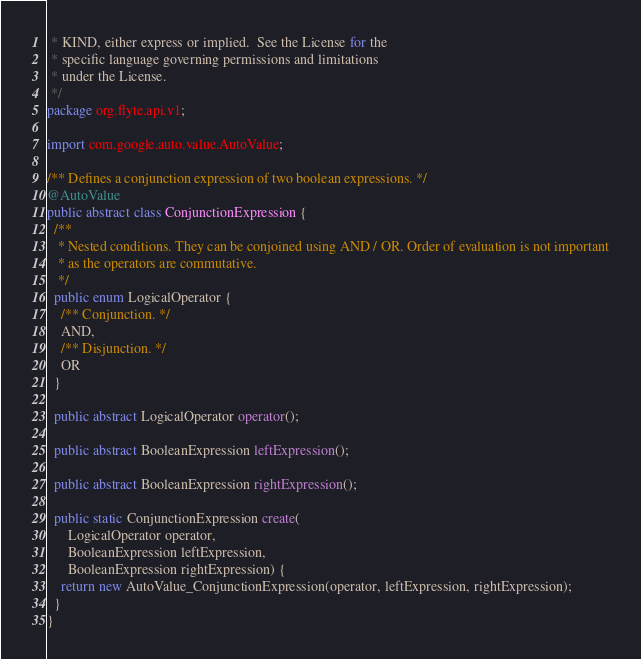<code> <loc_0><loc_0><loc_500><loc_500><_Java_> * KIND, either express or implied.  See the License for the
 * specific language governing permissions and limitations
 * under the License.
 */
package org.flyte.api.v1;

import com.google.auto.value.AutoValue;

/** Defines a conjunction expression of two boolean expressions. */
@AutoValue
public abstract class ConjunctionExpression {
  /**
   * Nested conditions. They can be conjoined using AND / OR. Order of evaluation is not important
   * as the operators are commutative.
   */
  public enum LogicalOperator {
    /** Conjunction. */
    AND,
    /** Disjunction. */
    OR
  }

  public abstract LogicalOperator operator();

  public abstract BooleanExpression leftExpression();

  public abstract BooleanExpression rightExpression();

  public static ConjunctionExpression create(
      LogicalOperator operator,
      BooleanExpression leftExpression,
      BooleanExpression rightExpression) {
    return new AutoValue_ConjunctionExpression(operator, leftExpression, rightExpression);
  }
}
</code> 